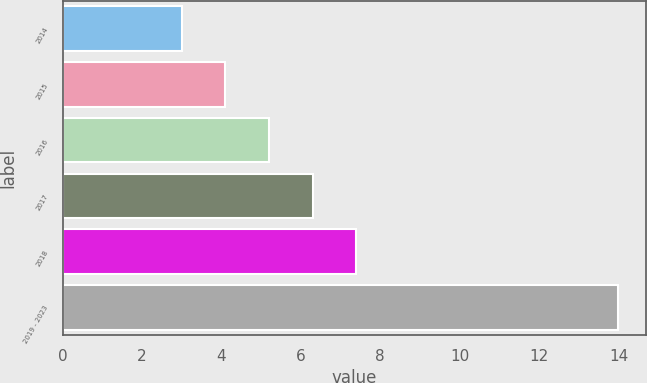<chart> <loc_0><loc_0><loc_500><loc_500><bar_chart><fcel>2014<fcel>2015<fcel>2016<fcel>2017<fcel>2018<fcel>2019 - 2023<nl><fcel>3<fcel>4.1<fcel>5.2<fcel>6.3<fcel>7.4<fcel>14<nl></chart> 